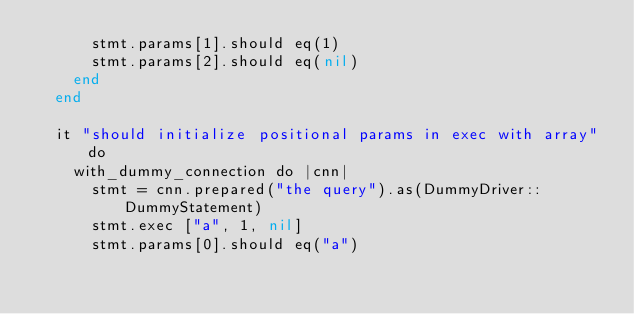<code> <loc_0><loc_0><loc_500><loc_500><_Crystal_>      stmt.params[1].should eq(1)
      stmt.params[2].should eq(nil)
    end
  end

  it "should initialize positional params in exec with array" do
    with_dummy_connection do |cnn|
      stmt = cnn.prepared("the query").as(DummyDriver::DummyStatement)
      stmt.exec ["a", 1, nil]
      stmt.params[0].should eq("a")</code> 